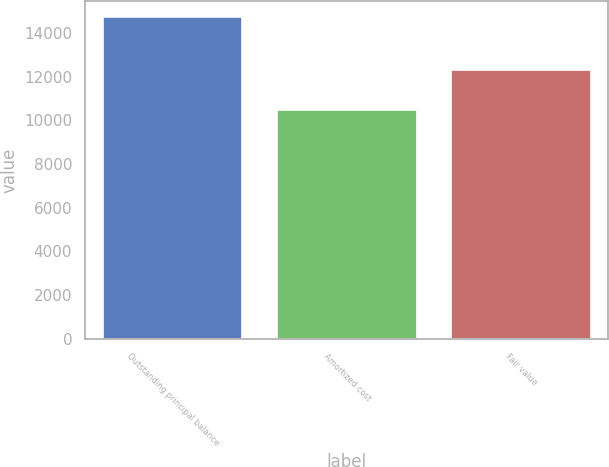Convert chart to OTSL. <chart><loc_0><loc_0><loc_500><loc_500><bar_chart><fcel>Outstanding principal balance<fcel>Amortized cost<fcel>Fair value<nl><fcel>14718<fcel>10492<fcel>12293<nl></chart> 